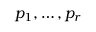Convert formula to latex. <formula><loc_0><loc_0><loc_500><loc_500>p _ { 1 } , \dots , p _ { r }</formula> 